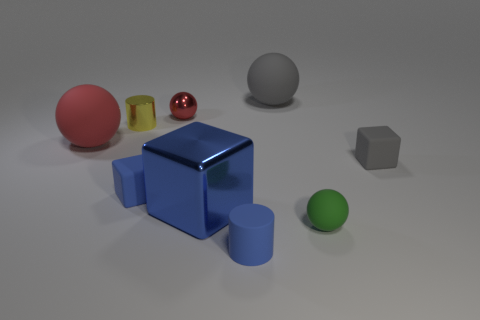Do the yellow cylinder and the red rubber object have the same size?
Give a very brief answer. No. What is the color of the metal thing in front of the red object left of the small cube left of the gray block?
Provide a short and direct response. Blue. How many shiny blocks have the same color as the small rubber cylinder?
Your response must be concise. 1. What number of large objects are either blue metallic blocks or yellow metallic cylinders?
Provide a short and direct response. 1. Are there any small gray objects of the same shape as the tiny red object?
Offer a terse response. No. Is the shape of the tiny gray thing the same as the tiny red object?
Give a very brief answer. No. What is the color of the large object that is to the right of the blue matte thing in front of the small rubber sphere?
Your answer should be compact. Gray. There is a shiny object that is the same size as the metallic cylinder; what color is it?
Offer a very short reply. Red. What number of rubber objects are either large brown objects or small blue things?
Keep it short and to the point. 2. There is a matte block that is right of the big gray thing; how many matte cylinders are behind it?
Ensure brevity in your answer.  0. 